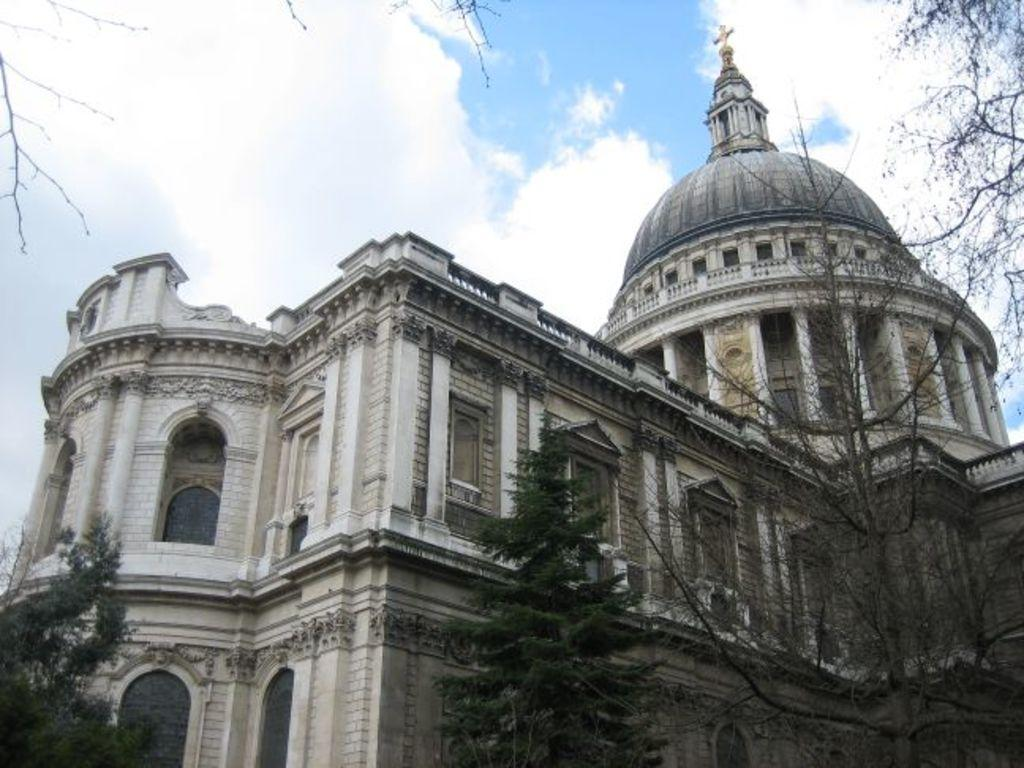What type of vegetation is at the bottom of the image? There are trees at the bottom of the image. What structure is located behind the trees? There is a building behind the trees. What can be seen in the sky at the top of the image? There are clouds visible in the sky at the top of the image. Can you tell me how many hens are perched on the branches of the trees in the image? There are no hens present in the image; it features trees and a building. What type of juice is being served in the building in the image? There is no juice or indication of any beverage being served in the image. 